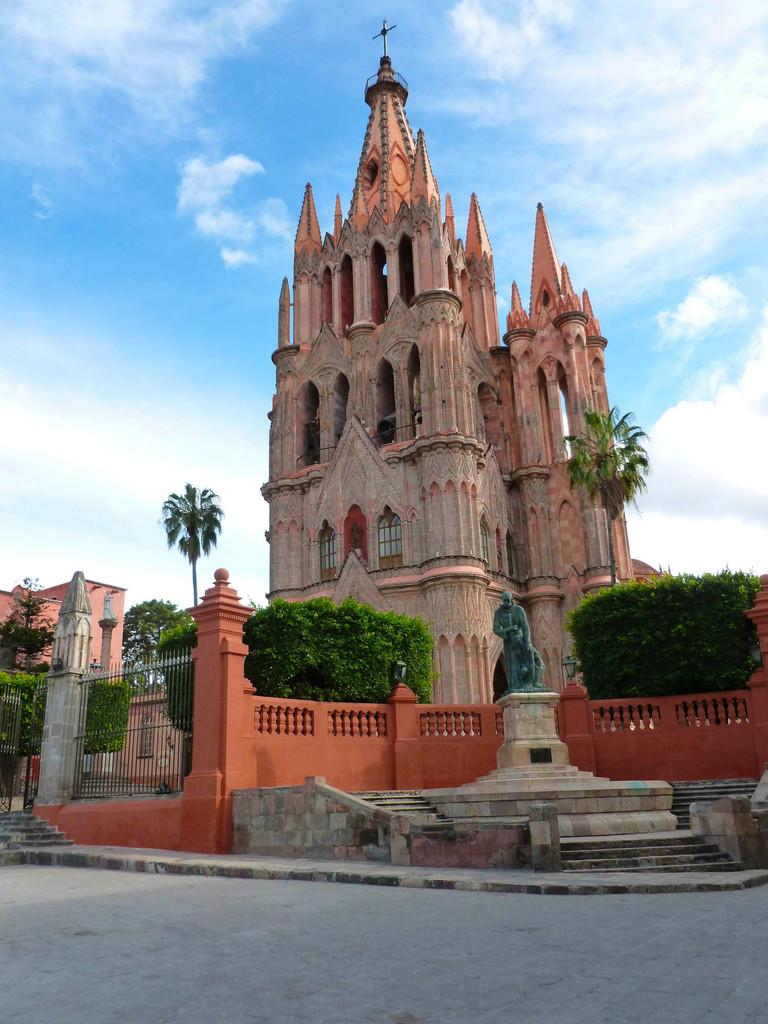What type of structure is visible in the image? There is a building with windows in the image. What type of barrier is present in the image? There is a metal fence in the image. What type of architectural feature can be seen in the image? There is a wall in the image. What type of feature allows for vertical movement in the image? There is a staircase in the image. What type of artwork is present in the image? There is a statue in the image. What type of living organisms can be seen in the image? Plants and trees are visible in the image. What part of the natural environment is visible in the image? The sky is visible in the image. What is the weather like in the image? The sky appears cloudy in the image. How many nuts are being pushed by the group in the image? There is no group or nuts present in the image. What type of nut is being used to create the artwork in the image? There is no artwork made of nuts in the image. 